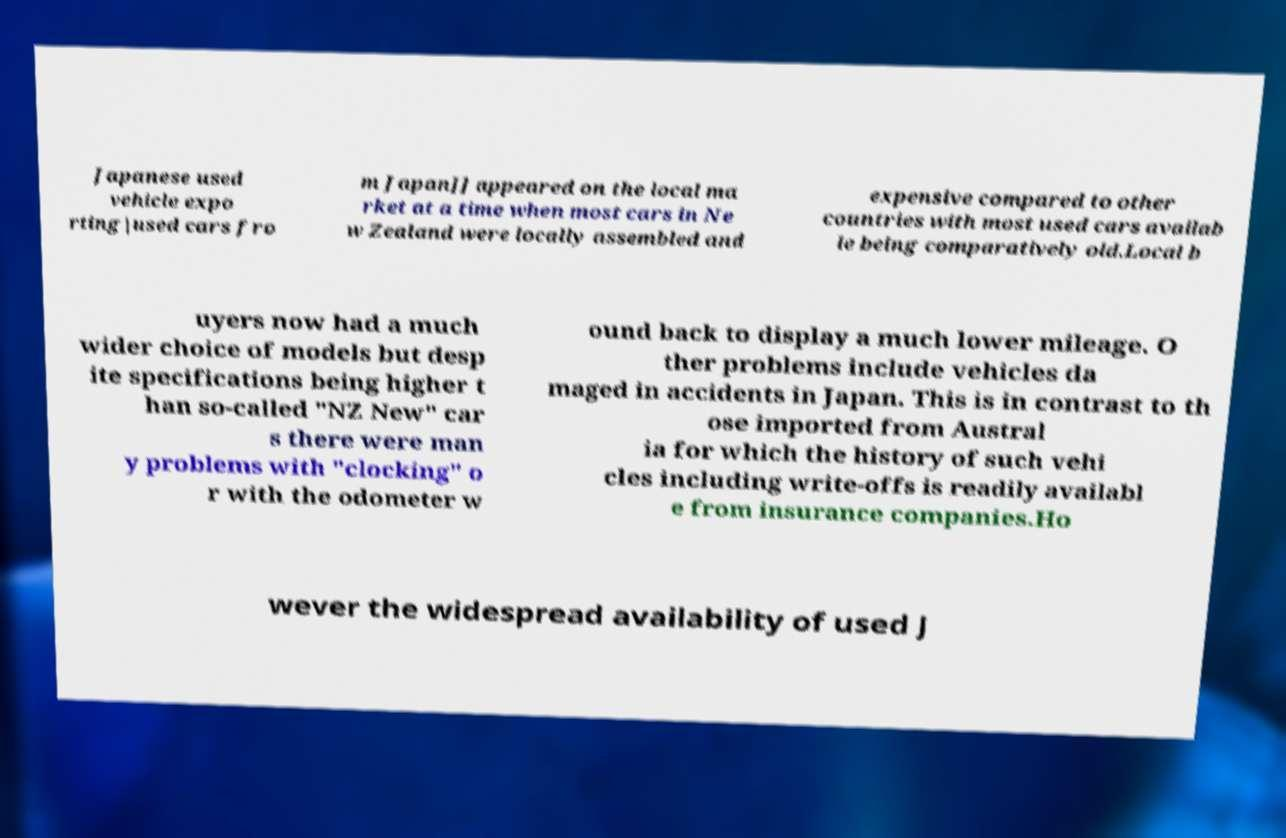Could you extract and type out the text from this image? Japanese used vehicle expo rting|used cars fro m Japan]] appeared on the local ma rket at a time when most cars in Ne w Zealand were locally assembled and expensive compared to other countries with most used cars availab le being comparatively old.Local b uyers now had a much wider choice of models but desp ite specifications being higher t han so-called "NZ New" car s there were man y problems with "clocking" o r with the odometer w ound back to display a much lower mileage. O ther problems include vehicles da maged in accidents in Japan. This is in contrast to th ose imported from Austral ia for which the history of such vehi cles including write-offs is readily availabl e from insurance companies.Ho wever the widespread availability of used J 